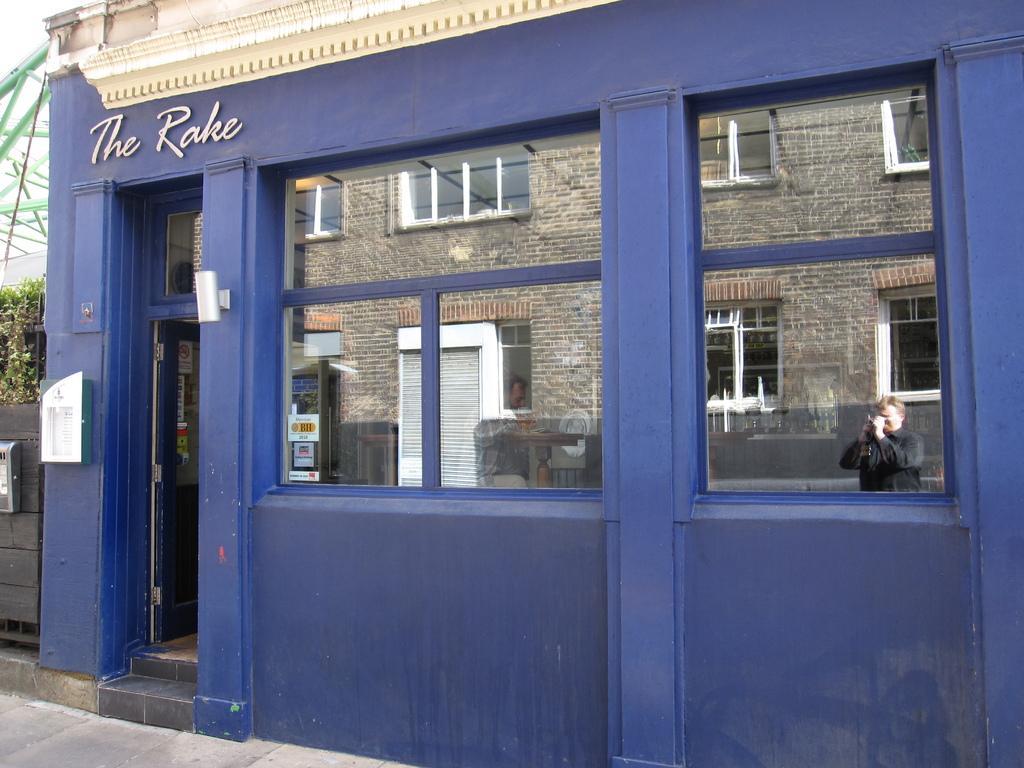Describe this image in one or two sentences. In this picture I can see a building in front and on the top of the building I see 2 words written and I see the glasses. On the reflection of the glass, I see a building and a person. Through the glasses I can see another person. On the left side of this image I see few plants. 